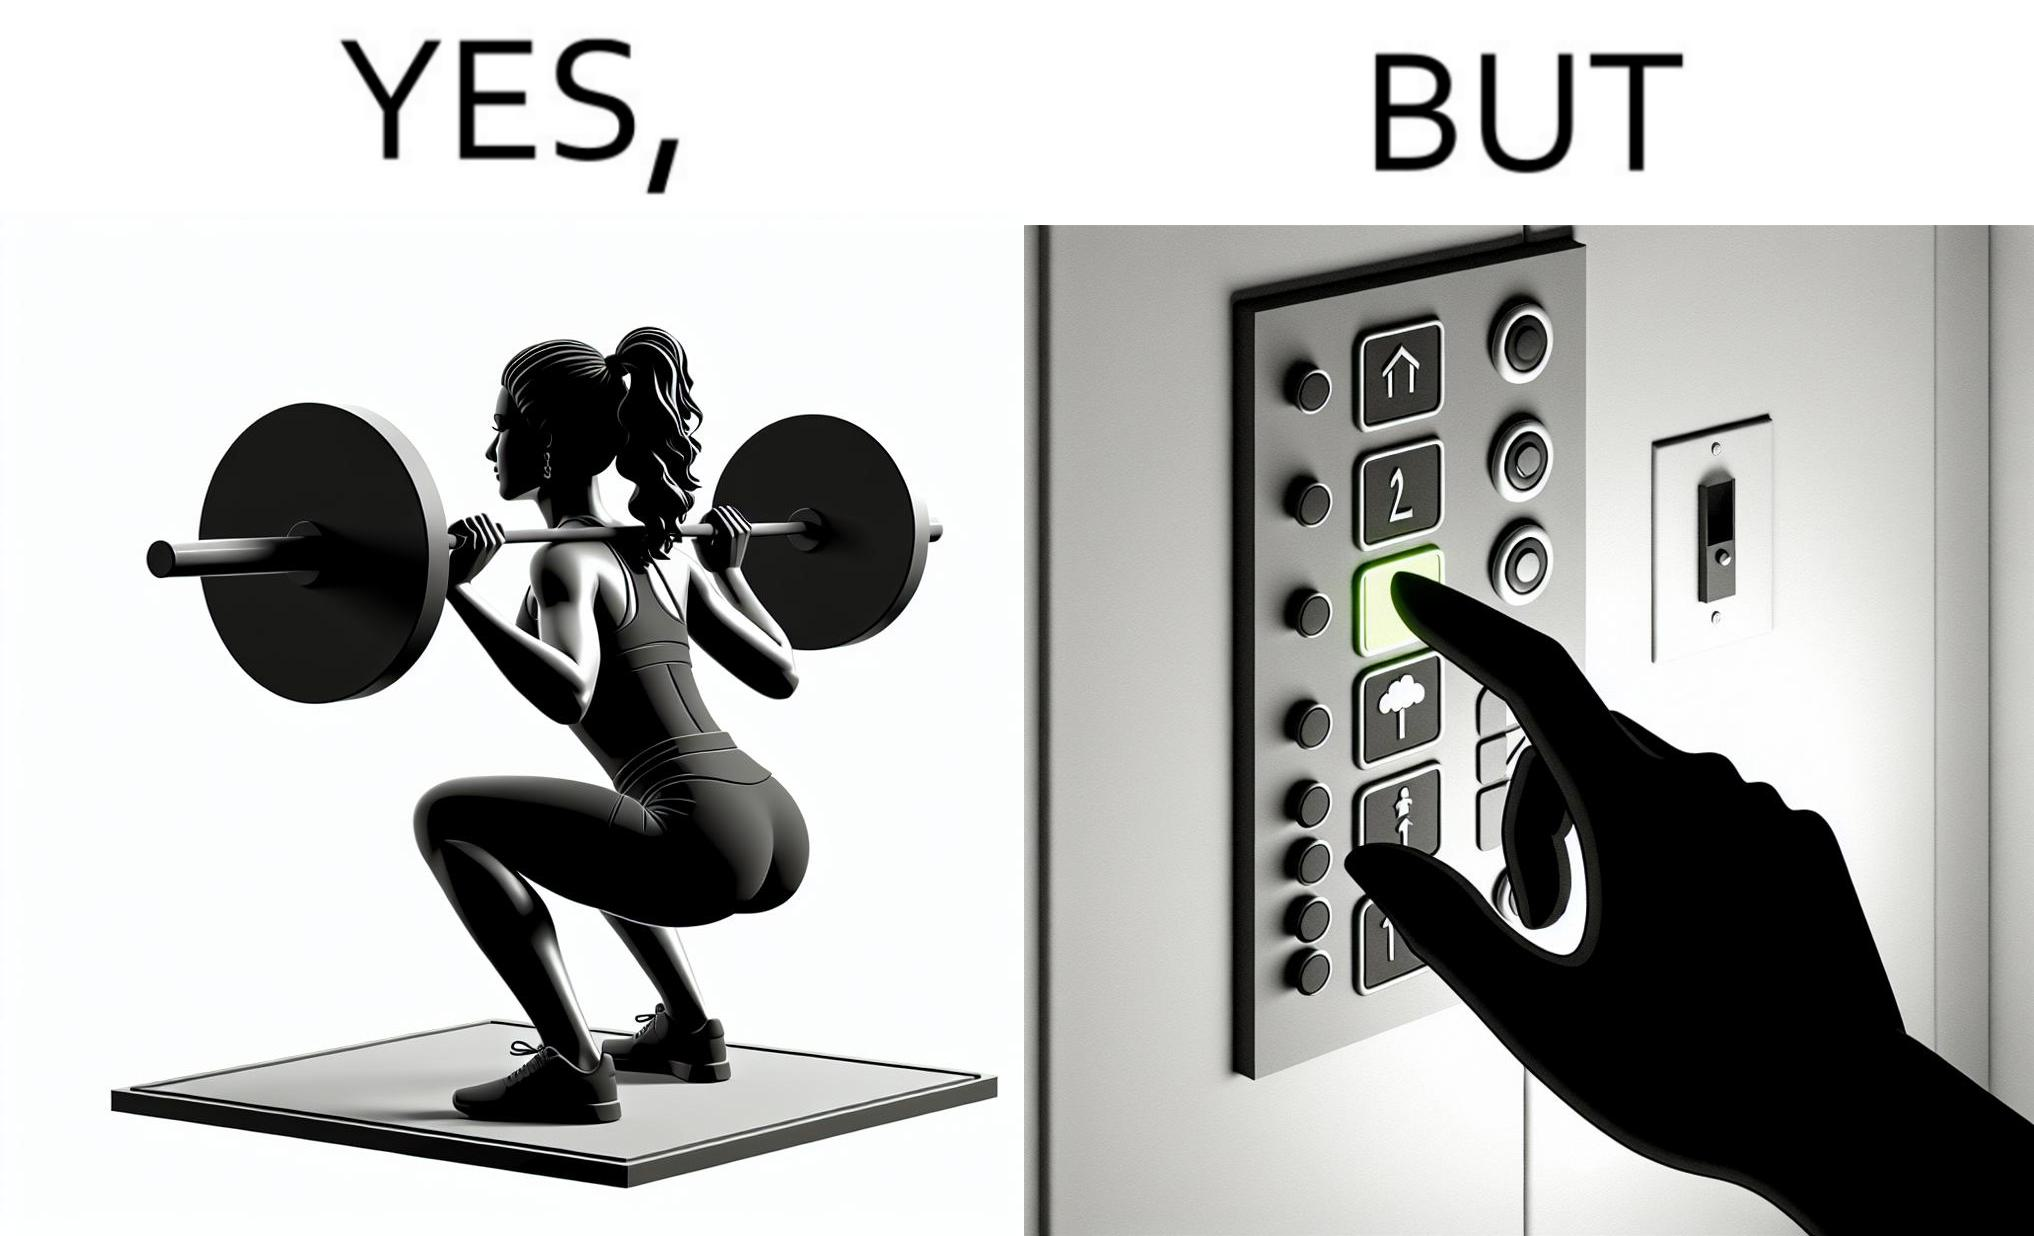Describe what you see in this image. The image is satirical because it shows that while people do various kinds of exercises and go to gym to stay fit, they avoid doing simplest of physical tasks like using stairs instead of elevators to get to even the first or the second floor of a building. 